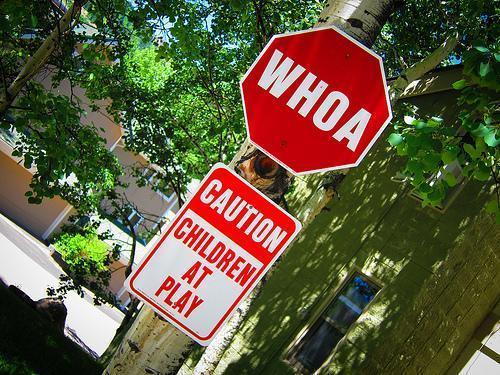How many signs are on the tree?
Give a very brief answer. 2. 